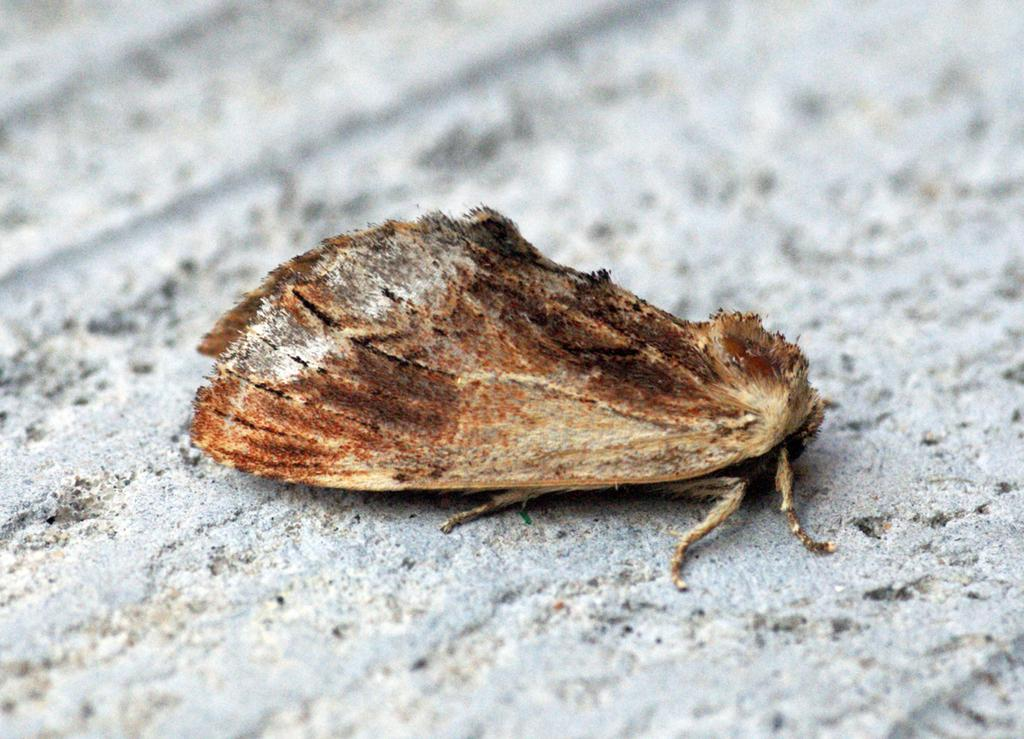What type of creature can be seen in the image? There is an insect in the image. Can you describe the background of the image? The background of the image is blurred. What tasks is the secretary performing in the image? There is no secretary present in the image; it features an insect and a blurred background. How does the sheet contribute to the taste of the dish in the image? There is no dish or sheet present in the image; it only features an insect and a blurred background. 